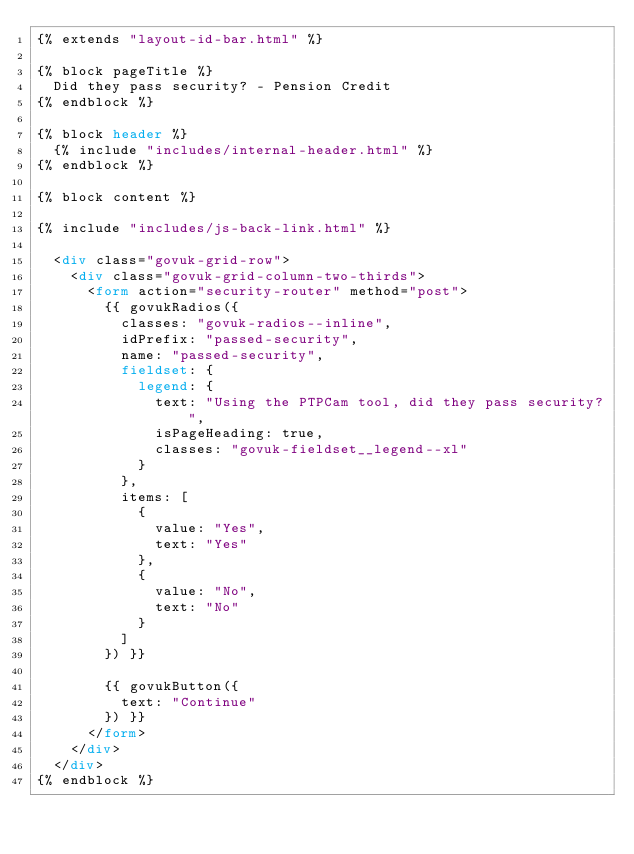Convert code to text. <code><loc_0><loc_0><loc_500><loc_500><_HTML_>{% extends "layout-id-bar.html" %}

{% block pageTitle %}
  Did they pass security? - Pension Credit
{% endblock %}

{% block header %}
  {% include "includes/internal-header.html" %}
{% endblock %}

{% block content %}

{% include "includes/js-back-link.html" %}

  <div class="govuk-grid-row">
    <div class="govuk-grid-column-two-thirds">
      <form action="security-router" method="post">
        {{ govukRadios({
          classes: "govuk-radios--inline",
          idPrefix: "passed-security",
          name: "passed-security",
          fieldset: {
            legend: {
              text: "Using the PTPCam tool, did they pass security?",
              isPageHeading: true,
              classes: "govuk-fieldset__legend--xl"
            }
          },
          items: [
            {
              value: "Yes",
              text: "Yes"
            },
            {
              value: "No",
              text: "No"
            }
          ]
        }) }}

        {{ govukButton({
          text: "Continue"
        }) }}
      </form>
    </div>
  </div>
{% endblock %}
</code> 